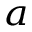<formula> <loc_0><loc_0><loc_500><loc_500>^ { a }</formula> 